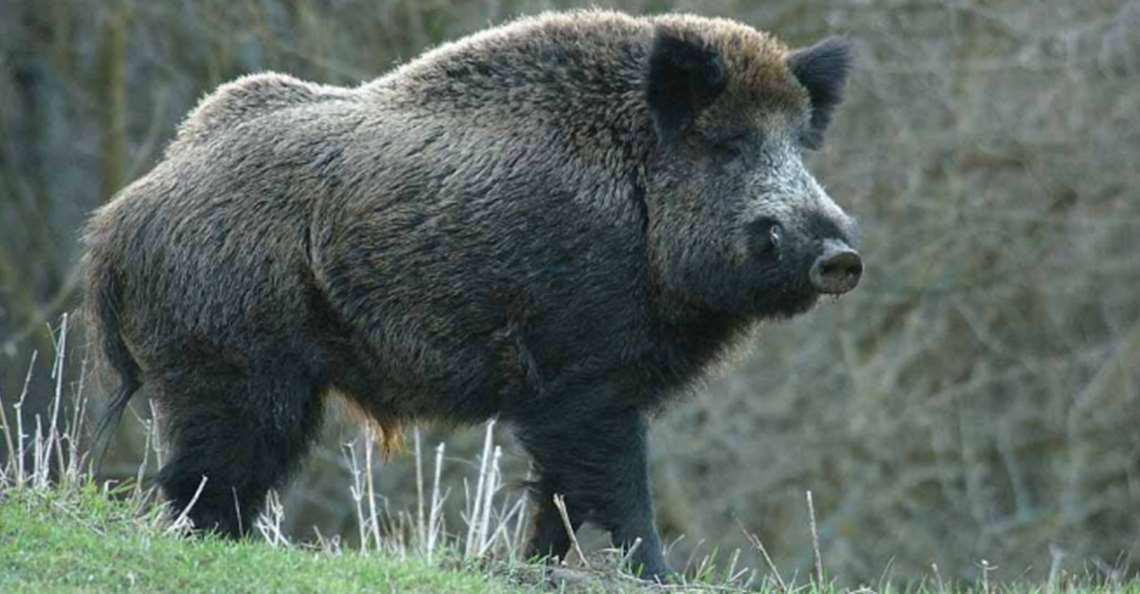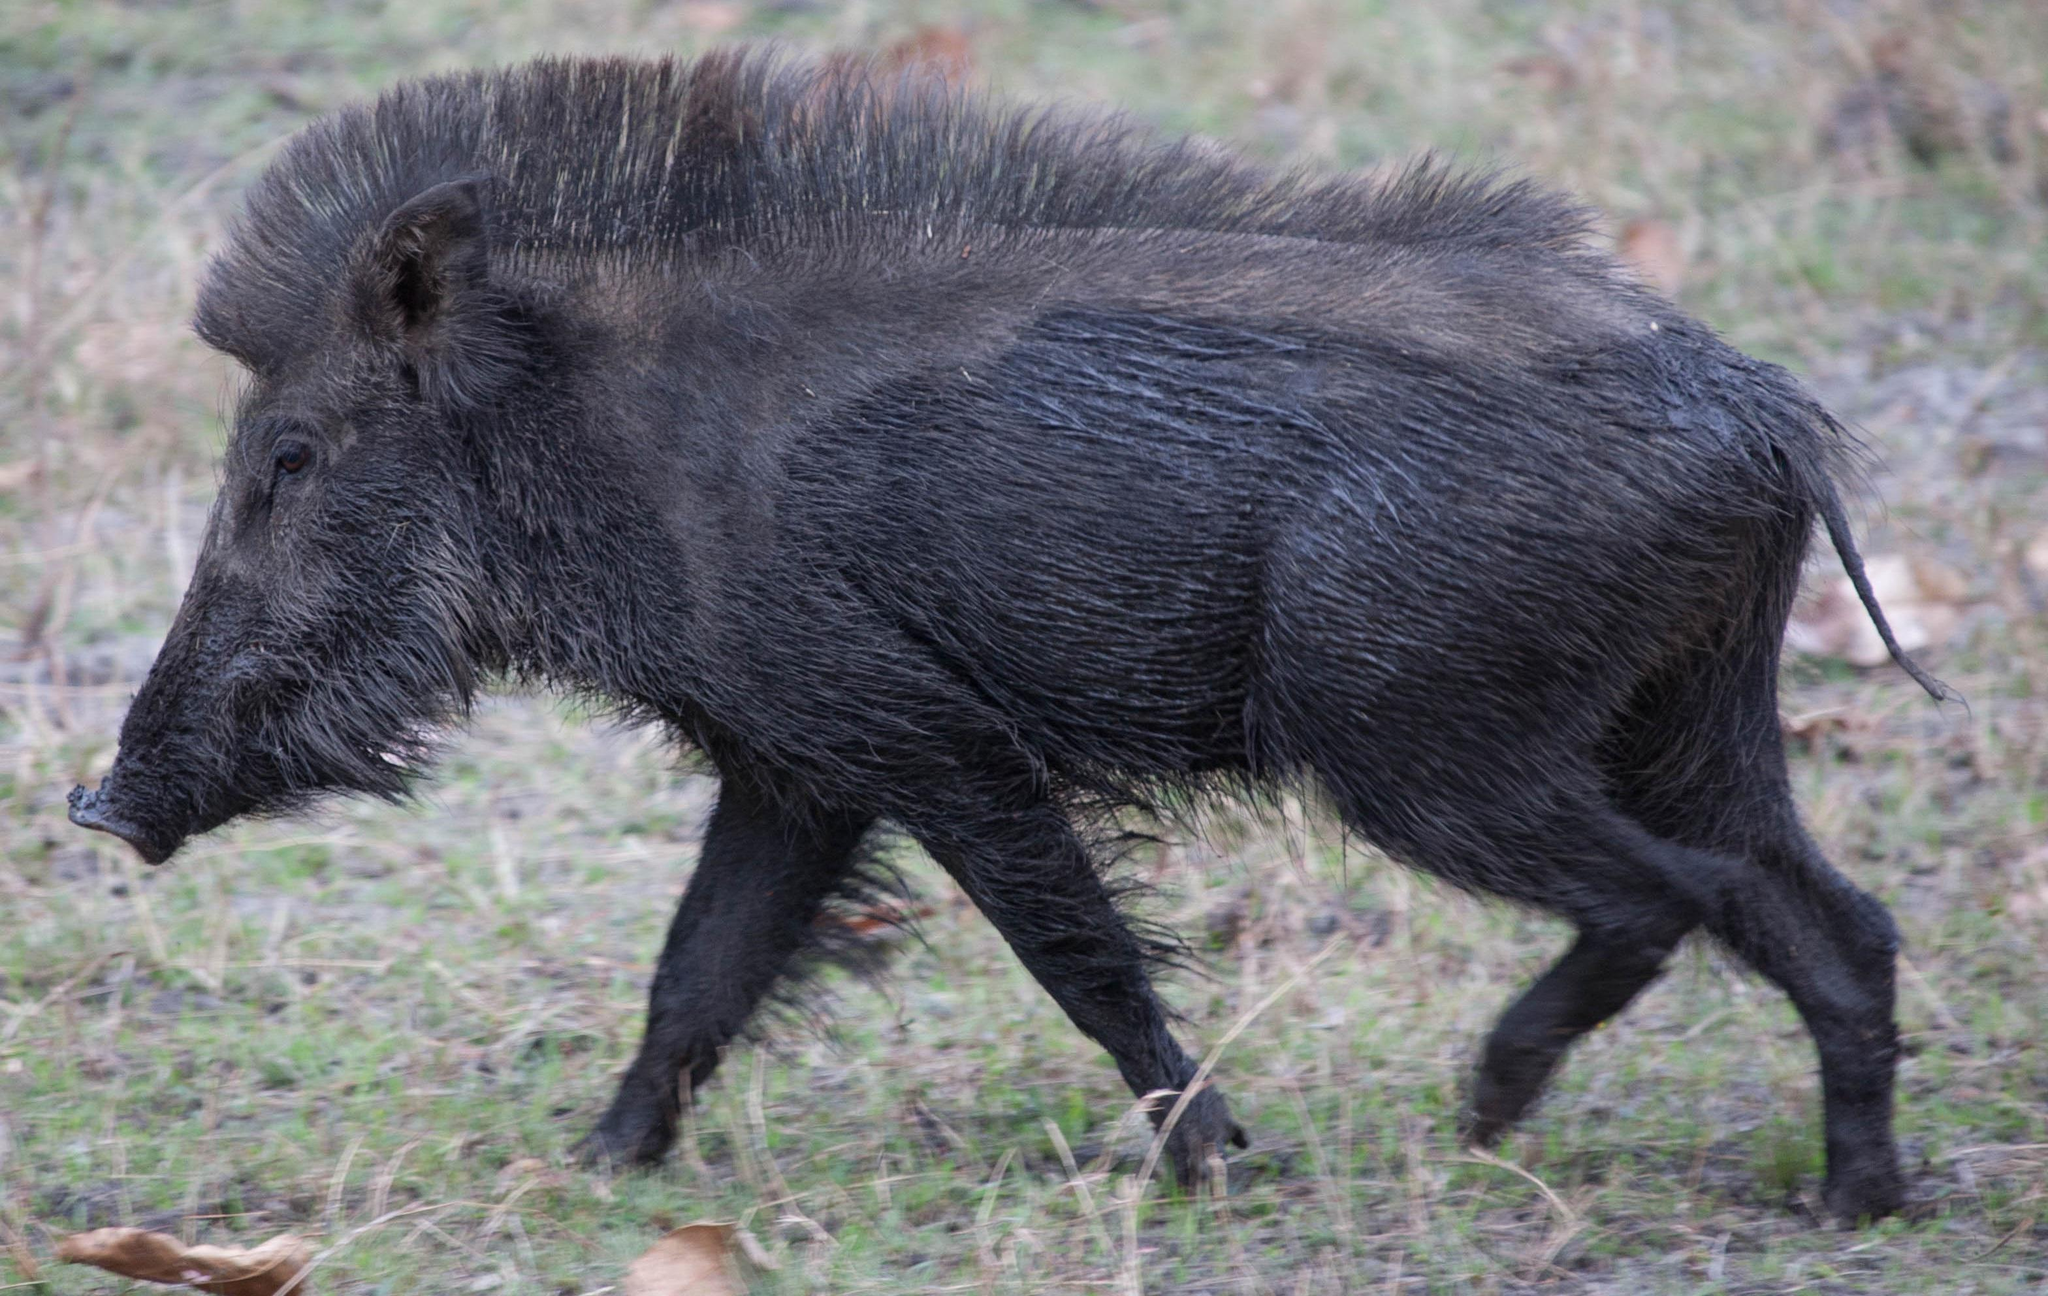The first image is the image on the left, the second image is the image on the right. For the images displayed, is the sentence "Each image contains a single wild pig, and the pigs in the right and left images appear to be facing each other." factually correct? Answer yes or no. Yes. The first image is the image on the left, the second image is the image on the right. Given the left and right images, does the statement "There are two hogs in the pair of images ,both facing each other." hold true? Answer yes or no. Yes. 